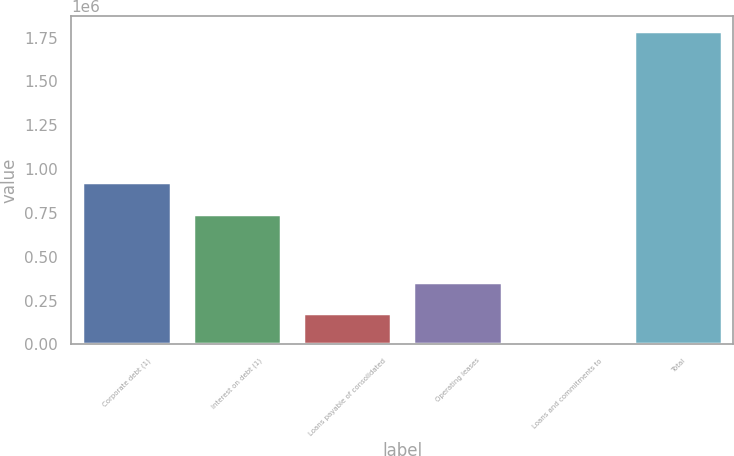Convert chart. <chart><loc_0><loc_0><loc_500><loc_500><bar_chart><fcel>Corporate debt (1)<fcel>Interest on debt (1)<fcel>Loans payable of consolidated<fcel>Operating leases<fcel>Loans and commitments to<fcel>Total<nl><fcel>927826<fcel>741712<fcel>178807<fcel>357336<fcel>279<fcel>1.78556e+06<nl></chart> 